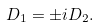Convert formula to latex. <formula><loc_0><loc_0><loc_500><loc_500>D _ { 1 } = \pm i D _ { 2 } .</formula> 